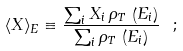<formula> <loc_0><loc_0><loc_500><loc_500>\langle X \rangle _ { E } \equiv \frac { \sum _ { i } X _ { i } \, \rho _ { T } \, \left ( E _ { i } \right ) } { \sum _ { i } \rho _ { T } \, \left ( E _ { i } \right ) } \ ;</formula> 